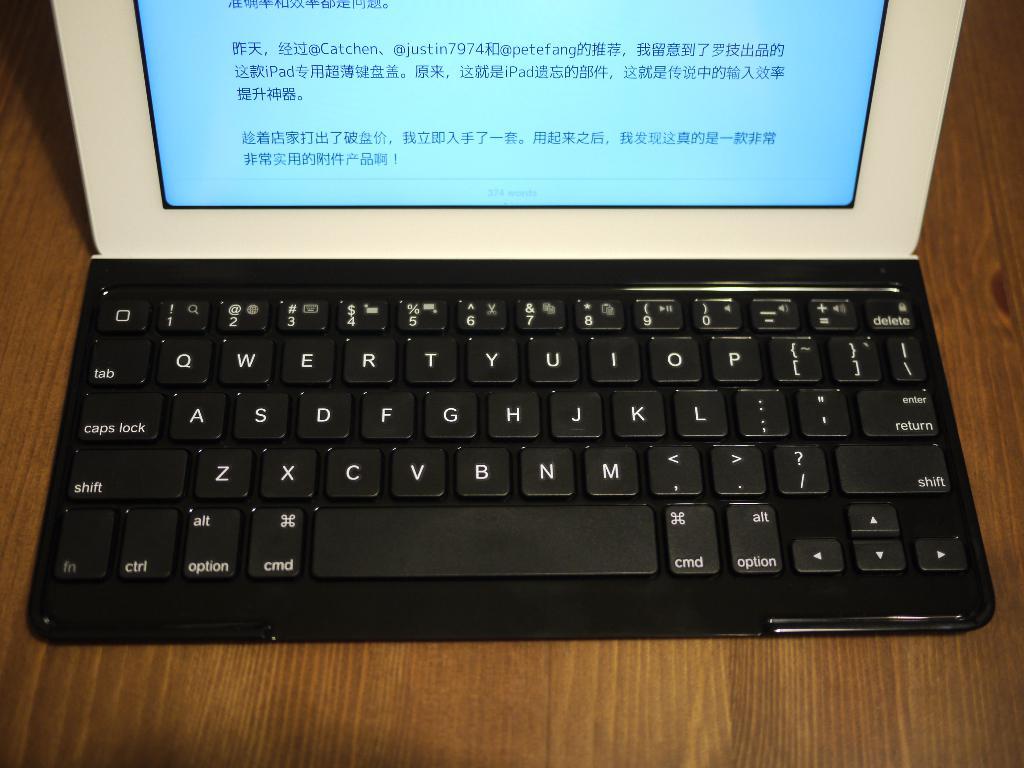What is the name of the key below the caps lock key?
Provide a succinct answer. Shift. What language is on the screen?
Give a very brief answer. Unanswerable. 